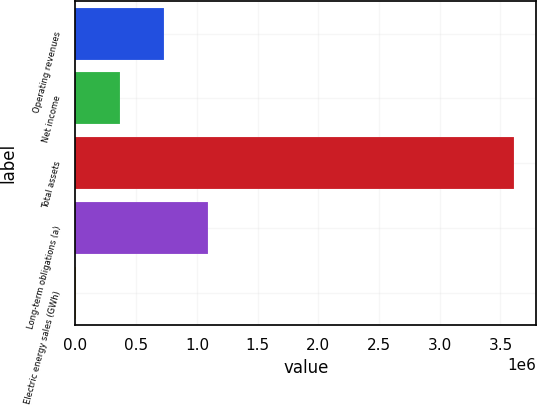Convert chart to OTSL. <chart><loc_0><loc_0><loc_500><loc_500><bar_chart><fcel>Operating revenues<fcel>Net income<fcel>Total assets<fcel>Long-term obligations (a)<fcel>Electric energy sales (GWh)<nl><fcel>728204<fcel>367403<fcel>3.61461e+06<fcel>1.089e+06<fcel>6602<nl></chart> 